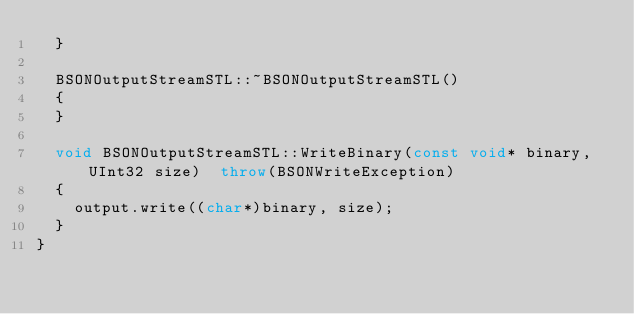Convert code to text. <code><loc_0><loc_0><loc_500><loc_500><_C++_>  }
  
  BSONOutputStreamSTL::~BSONOutputStreamSTL()
  {
  }
  
  void BSONOutputStreamSTL::WriteBinary(const void* binary, UInt32 size)  throw(BSONWriteException)
  {
    output.write((char*)binary, size);
  }
}
</code> 